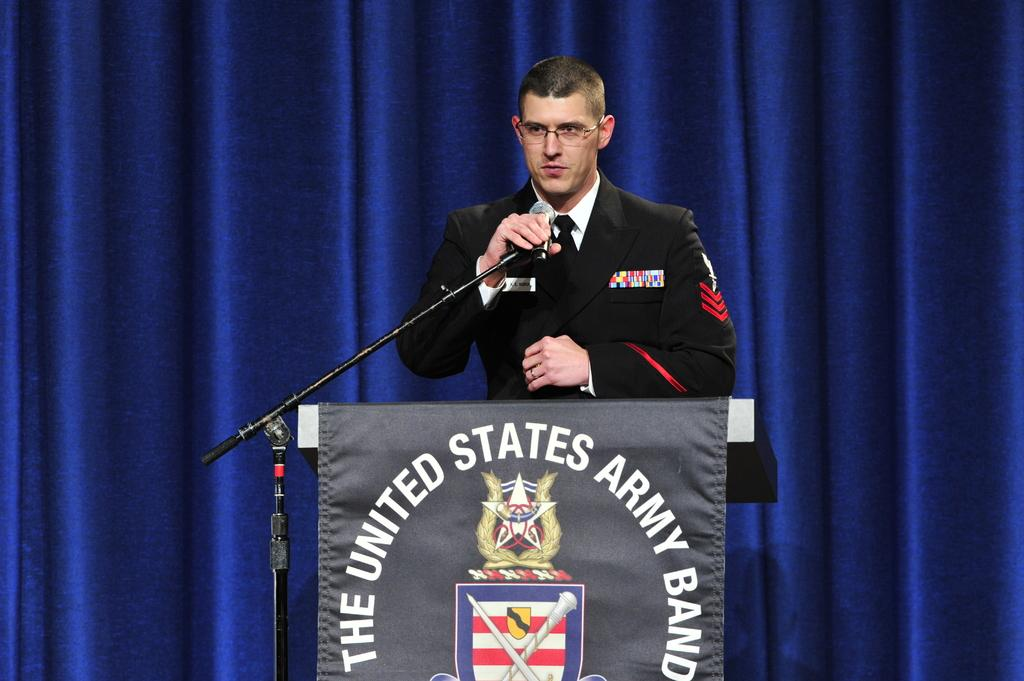<image>
Provide a brief description of the given image. A man wearing military uniform, standing at a podium that is draped with "The United States Army Band" logo in the front. 